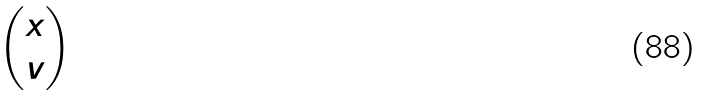<formula> <loc_0><loc_0><loc_500><loc_500>\begin{pmatrix} x \\ v \end{pmatrix}</formula> 